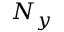Convert formula to latex. <formula><loc_0><loc_0><loc_500><loc_500>N _ { y }</formula> 